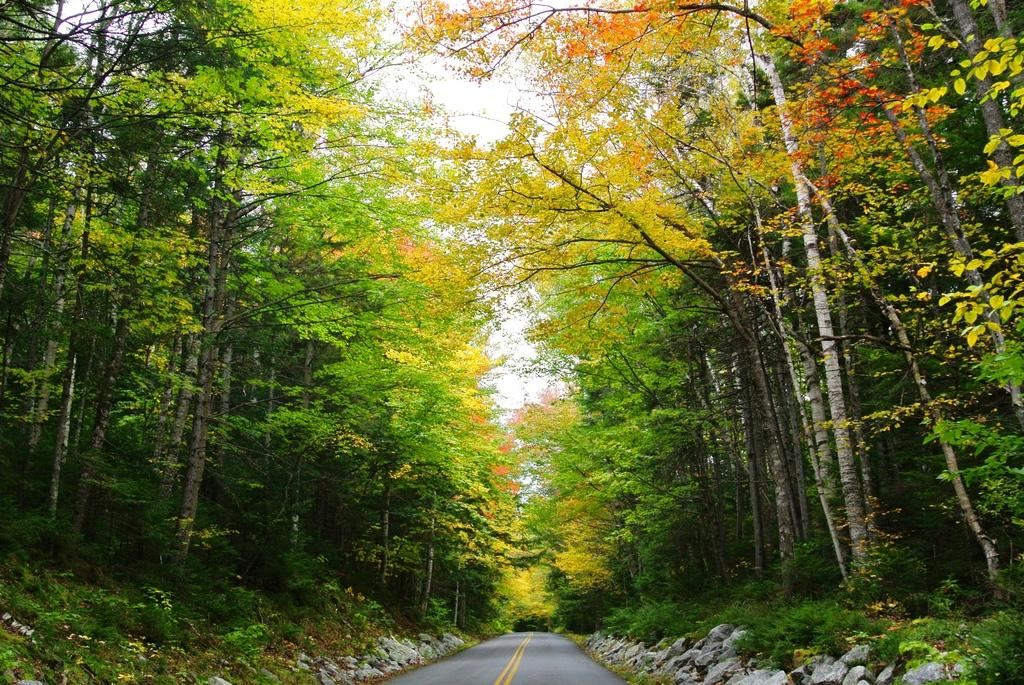What is the main feature of the image? There is a road in the image. What else can be seen alongside the road? There are rocks visible in the image. What type of vegetation is present on both sides of the road? There are green, yellow, and orange trees on both sides of the road. What can be seen in the background of the image? The sky is visible in the background of the image. What type of wax can be seen melting on the rocks in the image? There is no wax present in the image; it only features a road, rocks, trees, and the sky. 